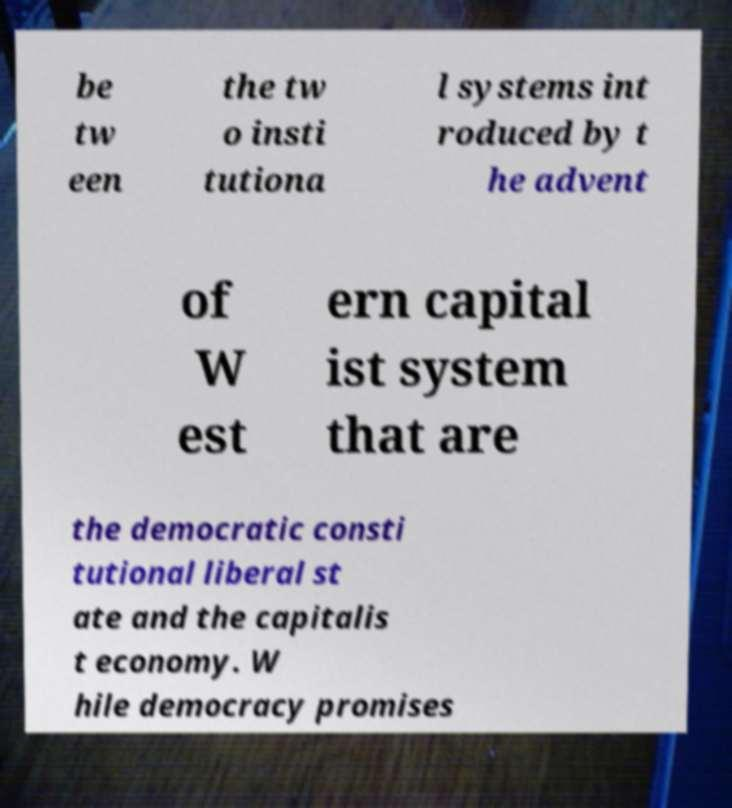I need the written content from this picture converted into text. Can you do that? be tw een the tw o insti tutiona l systems int roduced by t he advent of W est ern capital ist system that are the democratic consti tutional liberal st ate and the capitalis t economy. W hile democracy promises 